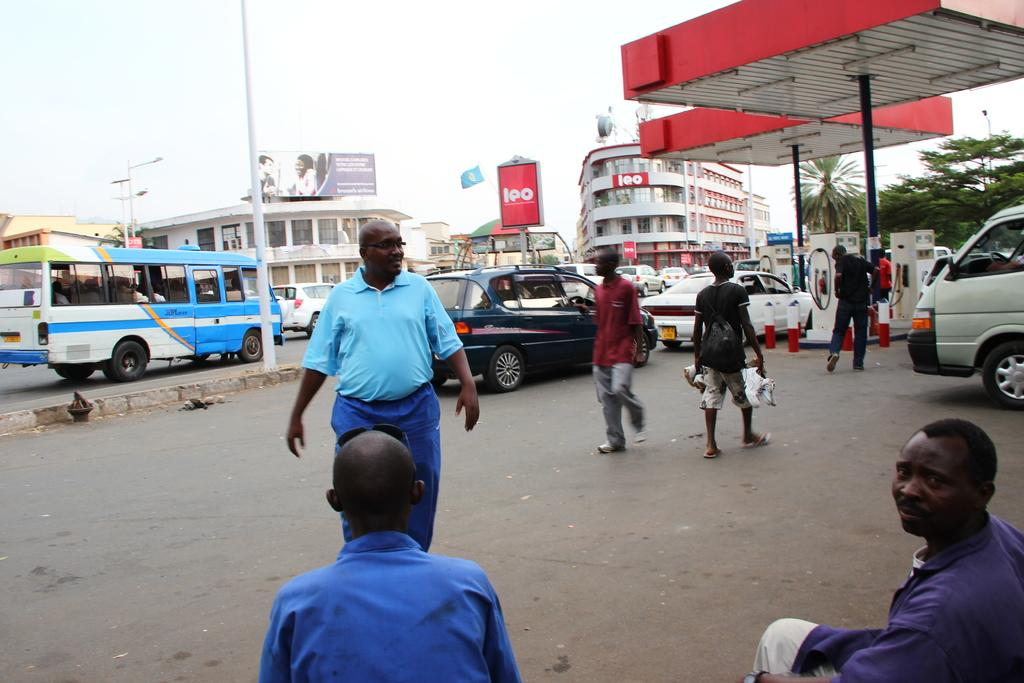How many people are in the image? There are people in the image, but the exact number is not specified. What are some of the people doing in the image? Some people are walking in the image. What else can be seen on the road in the image? There are vehicles on the road in the image. What is visible in the background of the image? In the background, there are buildings, lights on poles, trees, hoardings, and the sky. What type of drink is being consumed by the women in the image? There is no mention of women or any drink being consumed in the image. 